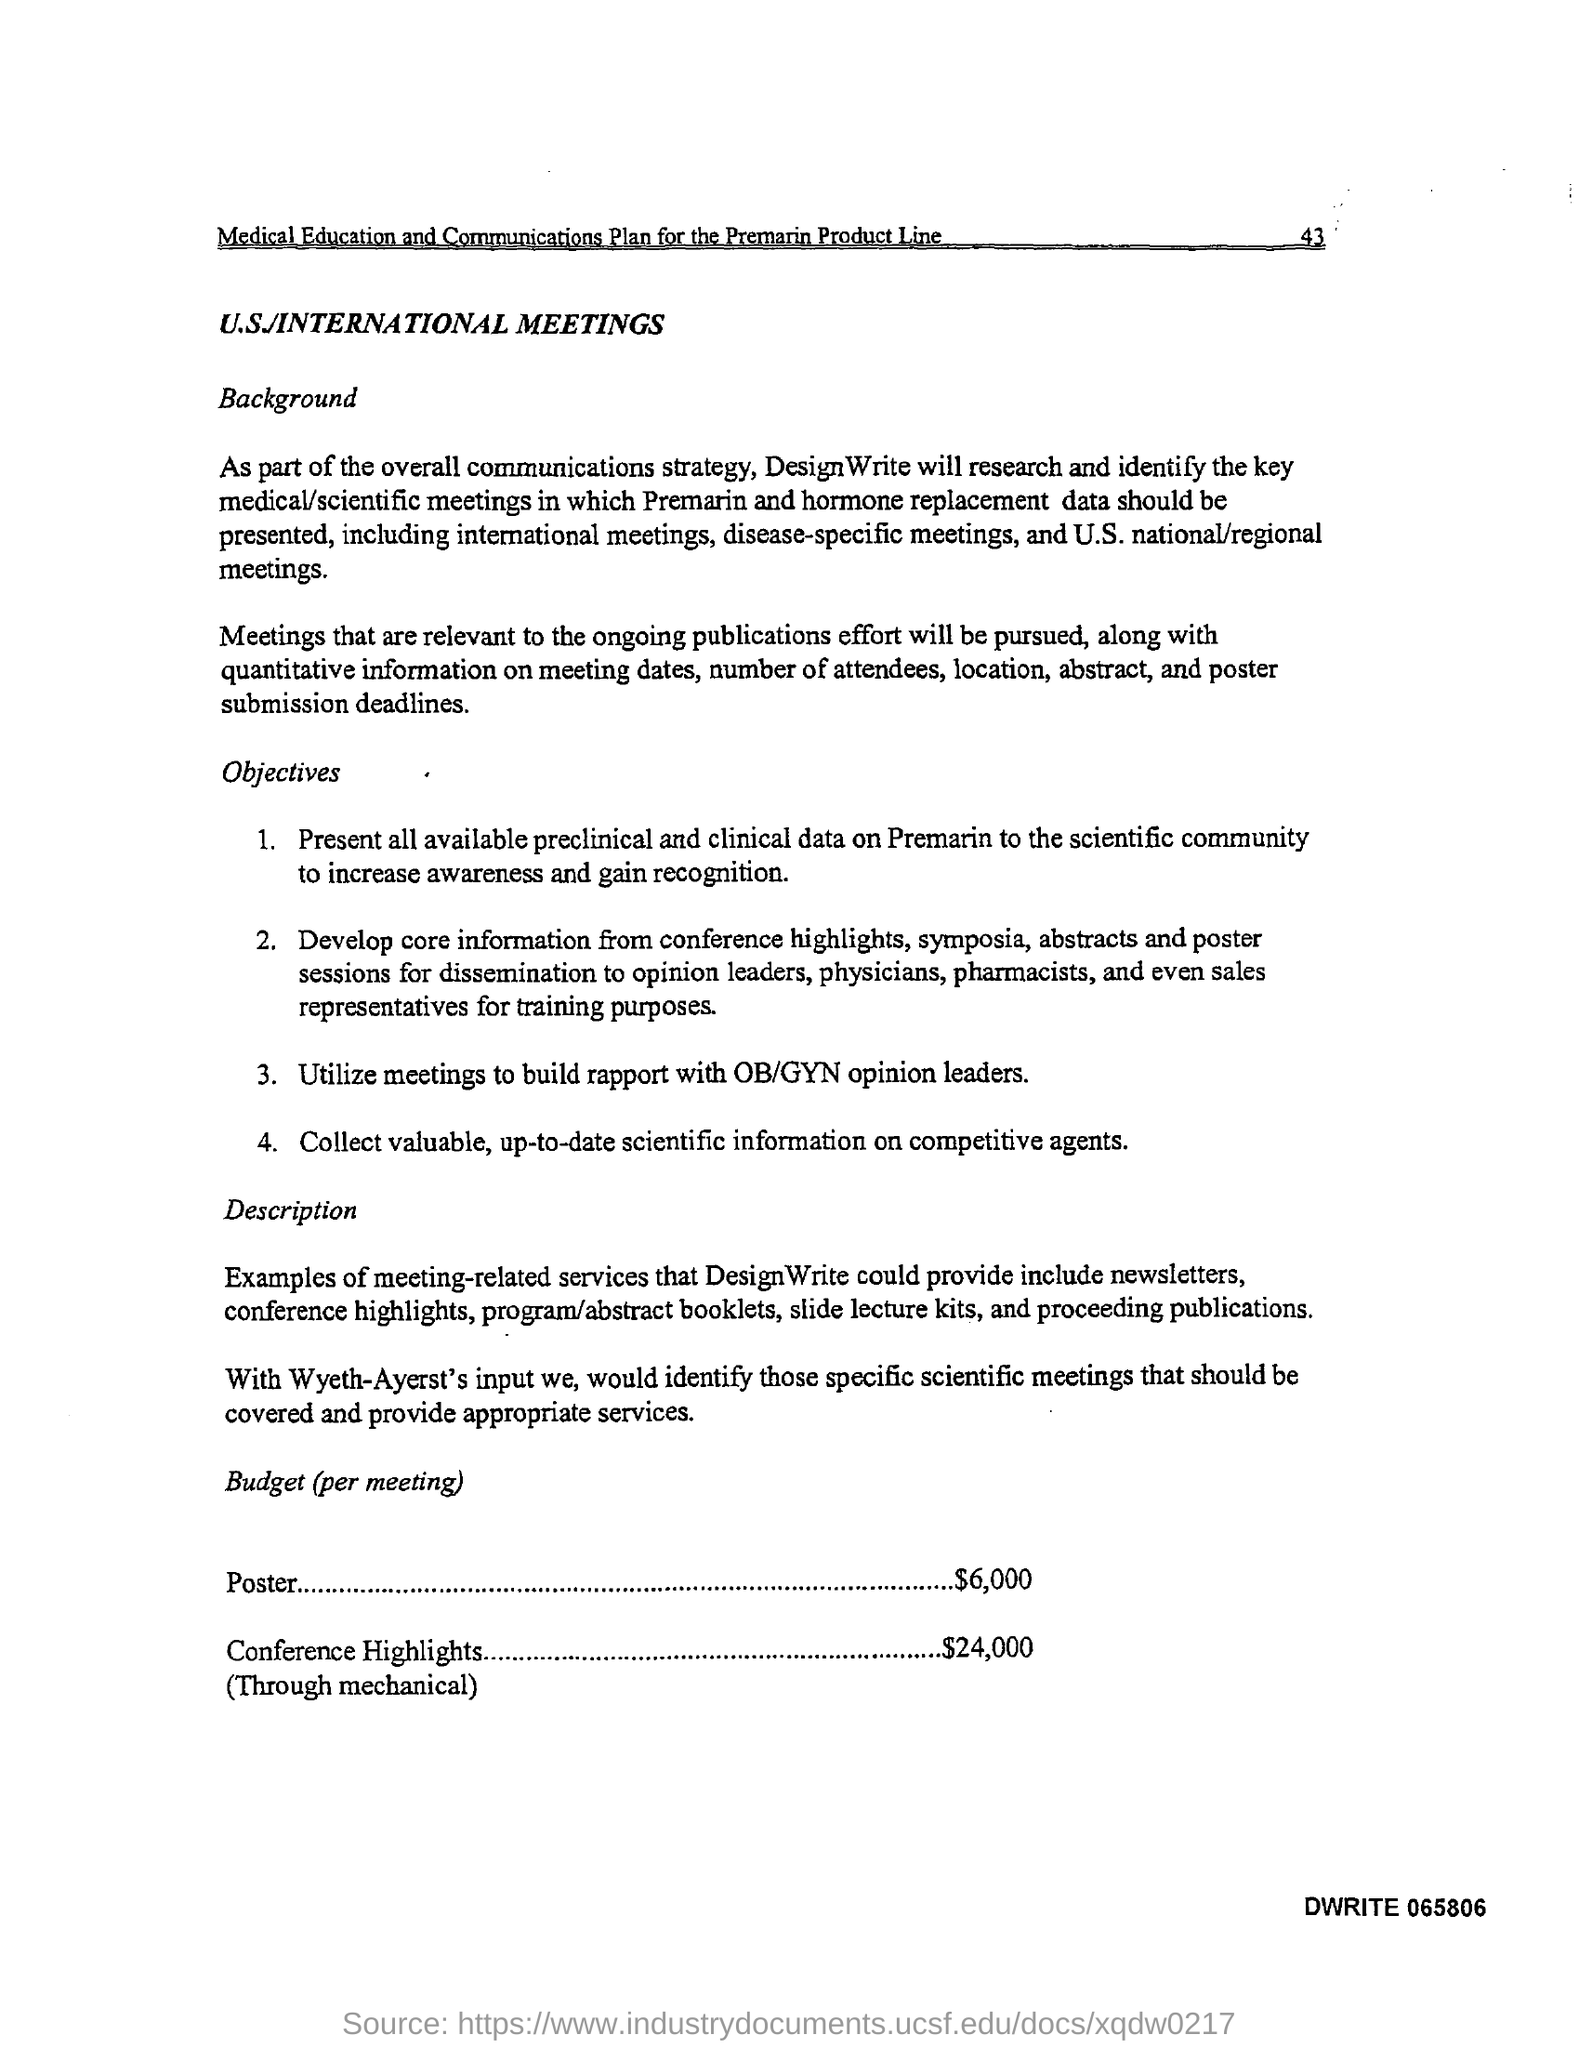List a handful of essential elements in this visual. The budget allocated for posters at each meeting is $6,000. The budget for conference highlights is $24,000. 